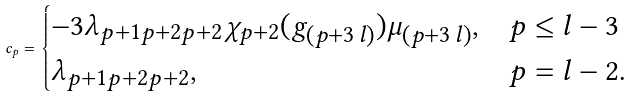Convert formula to latex. <formula><loc_0><loc_0><loc_500><loc_500>c _ { p } = \begin{cases} - 3 \lambda _ { p + 1 p + 2 p + 2 } \chi _ { p + 2 } ( g _ { ( p + 3 \, l ) } ) \mu _ { ( p + 3 \, l ) } , & p \leq l - 3 \\ \lambda _ { p + 1 p + 2 p + 2 } , & p = l - 2 . \end{cases}</formula> 